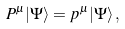Convert formula to latex. <formula><loc_0><loc_0><loc_500><loc_500>P ^ { \mu } | \Psi \rangle = p ^ { \mu } | \Psi \rangle \, ,</formula> 